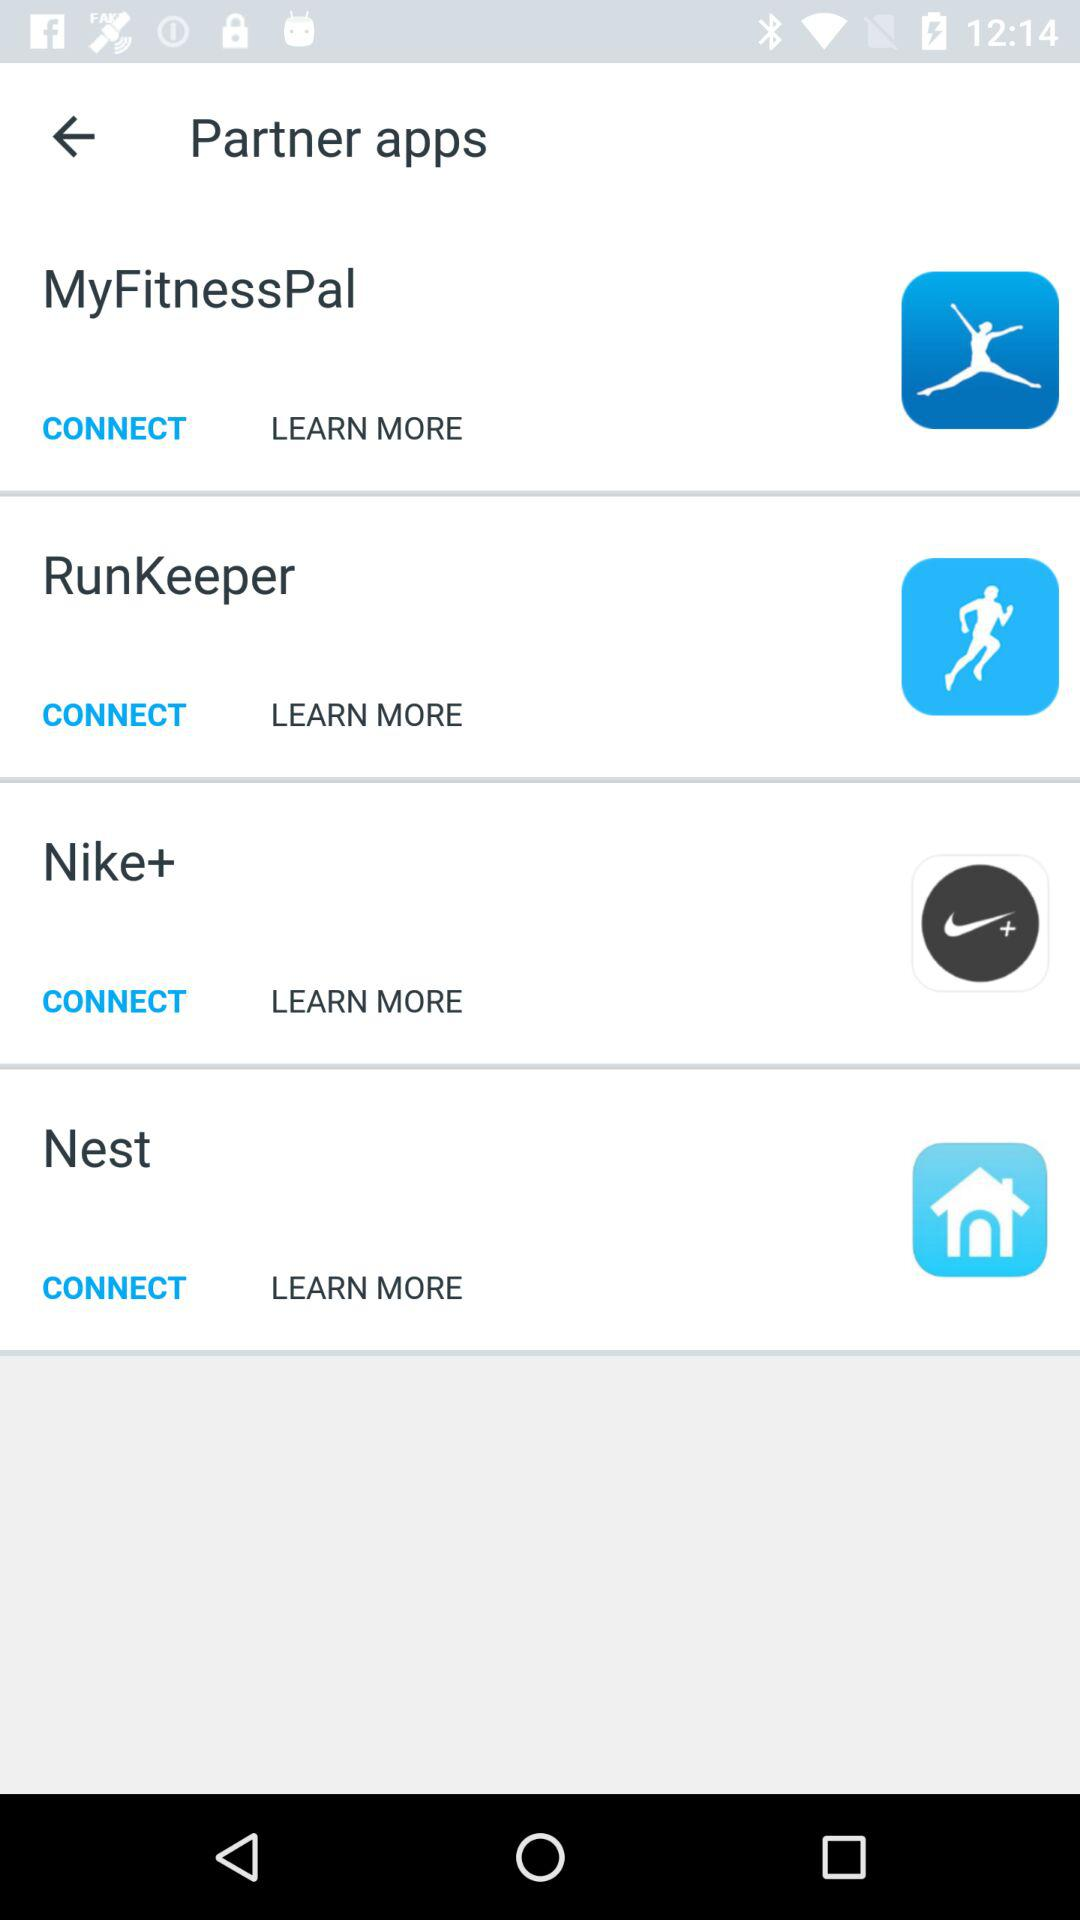How many partner apps are there?
Answer the question using a single word or phrase. 4 